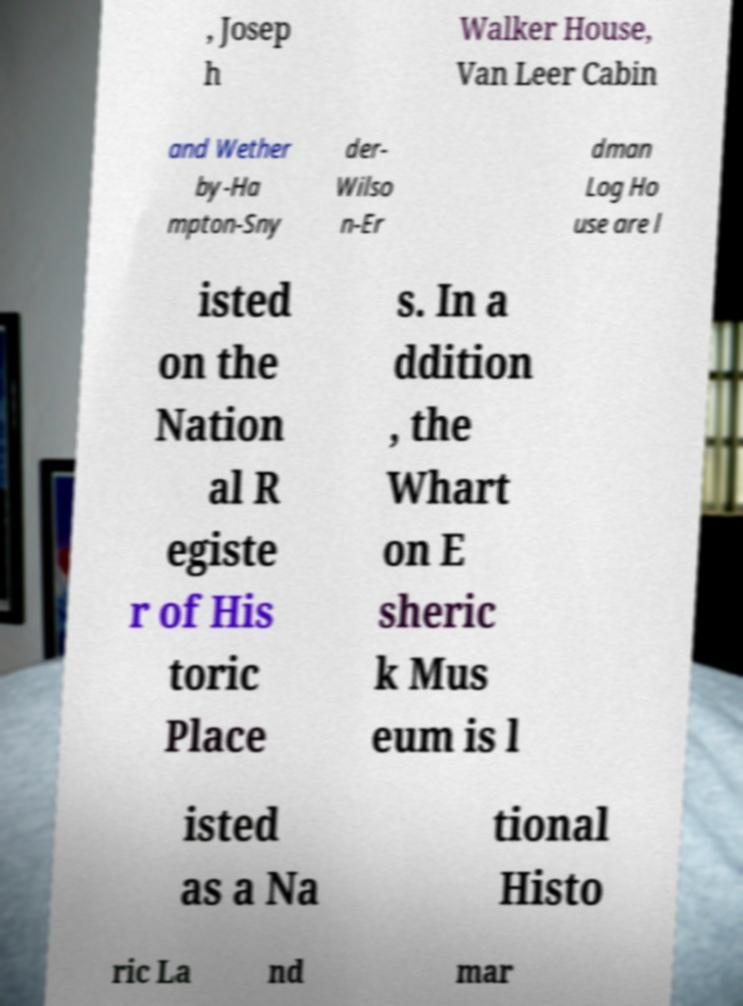There's text embedded in this image that I need extracted. Can you transcribe it verbatim? , Josep h Walker House, Van Leer Cabin and Wether by-Ha mpton-Sny der- Wilso n-Er dman Log Ho use are l isted on the Nation al R egiste r of His toric Place s. In a ddition , the Whart on E sheric k Mus eum is l isted as a Na tional Histo ric La nd mar 